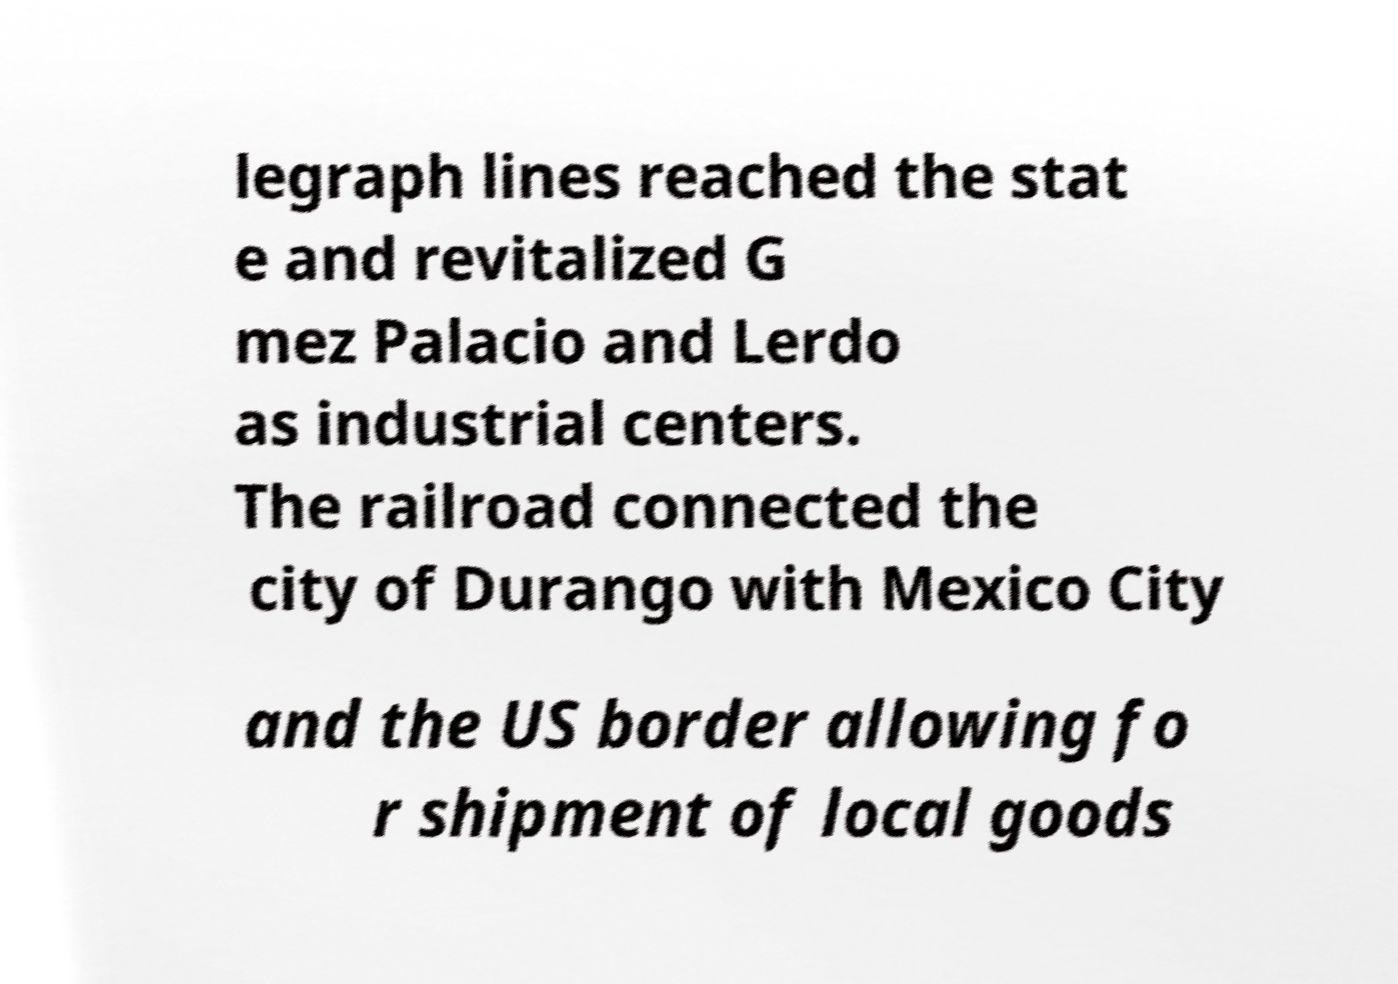What messages or text are displayed in this image? I need them in a readable, typed format. legraph lines reached the stat e and revitalized G mez Palacio and Lerdo as industrial centers. The railroad connected the city of Durango with Mexico City and the US border allowing fo r shipment of local goods 